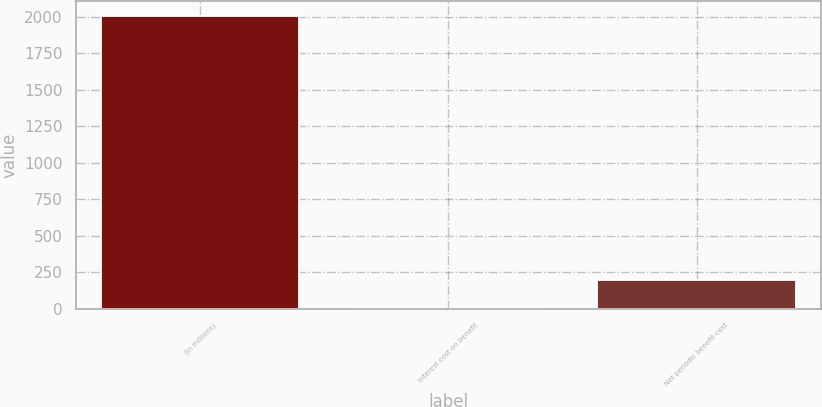Convert chart to OTSL. <chart><loc_0><loc_0><loc_500><loc_500><bar_chart><fcel>(In millions)<fcel>Interest cost on benefit<fcel>Net periodic benefit cost<nl><fcel>2006<fcel>0.2<fcel>200.78<nl></chart> 